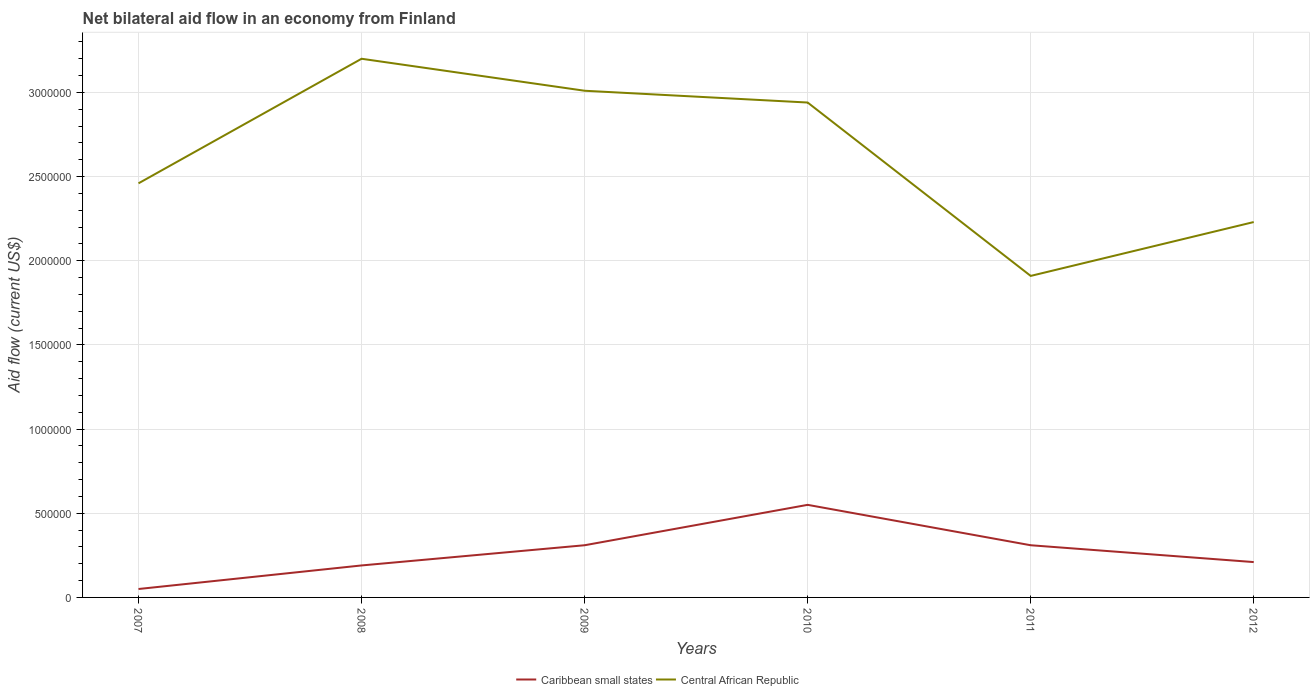Does the line corresponding to Central African Republic intersect with the line corresponding to Caribbean small states?
Give a very brief answer. No. Is the number of lines equal to the number of legend labels?
Your answer should be very brief. Yes. Across all years, what is the maximum net bilateral aid flow in Caribbean small states?
Provide a short and direct response. 5.00e+04. What is the total net bilateral aid flow in Central African Republic in the graph?
Your answer should be compact. 1.29e+06. What is the difference between the highest and the second highest net bilateral aid flow in Central African Republic?
Give a very brief answer. 1.29e+06. What is the difference between the highest and the lowest net bilateral aid flow in Central African Republic?
Your answer should be very brief. 3. Is the net bilateral aid flow in Caribbean small states strictly greater than the net bilateral aid flow in Central African Republic over the years?
Your response must be concise. Yes. How many lines are there?
Provide a short and direct response. 2. What is the difference between two consecutive major ticks on the Y-axis?
Give a very brief answer. 5.00e+05. Does the graph contain grids?
Your answer should be compact. Yes. What is the title of the graph?
Your answer should be compact. Net bilateral aid flow in an economy from Finland. Does "Cyprus" appear as one of the legend labels in the graph?
Your answer should be compact. No. What is the label or title of the Y-axis?
Your answer should be very brief. Aid flow (current US$). What is the Aid flow (current US$) of Central African Republic in 2007?
Your answer should be compact. 2.46e+06. What is the Aid flow (current US$) of Caribbean small states in 2008?
Offer a very short reply. 1.90e+05. What is the Aid flow (current US$) in Central African Republic in 2008?
Ensure brevity in your answer.  3.20e+06. What is the Aid flow (current US$) of Central African Republic in 2009?
Keep it short and to the point. 3.01e+06. What is the Aid flow (current US$) in Central African Republic in 2010?
Ensure brevity in your answer.  2.94e+06. What is the Aid flow (current US$) in Central African Republic in 2011?
Your answer should be compact. 1.91e+06. What is the Aid flow (current US$) in Central African Republic in 2012?
Provide a succinct answer. 2.23e+06. Across all years, what is the maximum Aid flow (current US$) of Central African Republic?
Offer a very short reply. 3.20e+06. Across all years, what is the minimum Aid flow (current US$) of Central African Republic?
Provide a short and direct response. 1.91e+06. What is the total Aid flow (current US$) of Caribbean small states in the graph?
Your response must be concise. 1.62e+06. What is the total Aid flow (current US$) of Central African Republic in the graph?
Provide a short and direct response. 1.58e+07. What is the difference between the Aid flow (current US$) in Caribbean small states in 2007 and that in 2008?
Offer a terse response. -1.40e+05. What is the difference between the Aid flow (current US$) of Central African Republic in 2007 and that in 2008?
Give a very brief answer. -7.40e+05. What is the difference between the Aid flow (current US$) in Central African Republic in 2007 and that in 2009?
Provide a succinct answer. -5.50e+05. What is the difference between the Aid flow (current US$) of Caribbean small states in 2007 and that in 2010?
Provide a succinct answer. -5.00e+05. What is the difference between the Aid flow (current US$) of Central African Republic in 2007 and that in 2010?
Offer a very short reply. -4.80e+05. What is the difference between the Aid flow (current US$) of Central African Republic in 2007 and that in 2011?
Your response must be concise. 5.50e+05. What is the difference between the Aid flow (current US$) in Caribbean small states in 2007 and that in 2012?
Offer a very short reply. -1.60e+05. What is the difference between the Aid flow (current US$) of Central African Republic in 2007 and that in 2012?
Your answer should be very brief. 2.30e+05. What is the difference between the Aid flow (current US$) of Caribbean small states in 2008 and that in 2009?
Give a very brief answer. -1.20e+05. What is the difference between the Aid flow (current US$) in Caribbean small states in 2008 and that in 2010?
Provide a succinct answer. -3.60e+05. What is the difference between the Aid flow (current US$) in Central African Republic in 2008 and that in 2010?
Make the answer very short. 2.60e+05. What is the difference between the Aid flow (current US$) in Central African Republic in 2008 and that in 2011?
Offer a terse response. 1.29e+06. What is the difference between the Aid flow (current US$) of Caribbean small states in 2008 and that in 2012?
Your answer should be very brief. -2.00e+04. What is the difference between the Aid flow (current US$) in Central African Republic in 2008 and that in 2012?
Provide a succinct answer. 9.70e+05. What is the difference between the Aid flow (current US$) of Central African Republic in 2009 and that in 2010?
Ensure brevity in your answer.  7.00e+04. What is the difference between the Aid flow (current US$) in Central African Republic in 2009 and that in 2011?
Ensure brevity in your answer.  1.10e+06. What is the difference between the Aid flow (current US$) in Central African Republic in 2009 and that in 2012?
Offer a very short reply. 7.80e+05. What is the difference between the Aid flow (current US$) of Caribbean small states in 2010 and that in 2011?
Keep it short and to the point. 2.40e+05. What is the difference between the Aid flow (current US$) of Central African Republic in 2010 and that in 2011?
Your answer should be compact. 1.03e+06. What is the difference between the Aid flow (current US$) in Caribbean small states in 2010 and that in 2012?
Your answer should be very brief. 3.40e+05. What is the difference between the Aid flow (current US$) of Central African Republic in 2010 and that in 2012?
Ensure brevity in your answer.  7.10e+05. What is the difference between the Aid flow (current US$) in Caribbean small states in 2011 and that in 2012?
Make the answer very short. 1.00e+05. What is the difference between the Aid flow (current US$) in Central African Republic in 2011 and that in 2012?
Your response must be concise. -3.20e+05. What is the difference between the Aid flow (current US$) of Caribbean small states in 2007 and the Aid flow (current US$) of Central African Republic in 2008?
Your answer should be compact. -3.15e+06. What is the difference between the Aid flow (current US$) in Caribbean small states in 2007 and the Aid flow (current US$) in Central African Republic in 2009?
Give a very brief answer. -2.96e+06. What is the difference between the Aid flow (current US$) in Caribbean small states in 2007 and the Aid flow (current US$) in Central African Republic in 2010?
Your answer should be compact. -2.89e+06. What is the difference between the Aid flow (current US$) of Caribbean small states in 2007 and the Aid flow (current US$) of Central African Republic in 2011?
Your answer should be very brief. -1.86e+06. What is the difference between the Aid flow (current US$) in Caribbean small states in 2007 and the Aid flow (current US$) in Central African Republic in 2012?
Provide a succinct answer. -2.18e+06. What is the difference between the Aid flow (current US$) of Caribbean small states in 2008 and the Aid flow (current US$) of Central African Republic in 2009?
Provide a succinct answer. -2.82e+06. What is the difference between the Aid flow (current US$) of Caribbean small states in 2008 and the Aid flow (current US$) of Central African Republic in 2010?
Your answer should be very brief. -2.75e+06. What is the difference between the Aid flow (current US$) in Caribbean small states in 2008 and the Aid flow (current US$) in Central African Republic in 2011?
Give a very brief answer. -1.72e+06. What is the difference between the Aid flow (current US$) in Caribbean small states in 2008 and the Aid flow (current US$) in Central African Republic in 2012?
Offer a terse response. -2.04e+06. What is the difference between the Aid flow (current US$) of Caribbean small states in 2009 and the Aid flow (current US$) of Central African Republic in 2010?
Your answer should be compact. -2.63e+06. What is the difference between the Aid flow (current US$) in Caribbean small states in 2009 and the Aid flow (current US$) in Central African Republic in 2011?
Offer a terse response. -1.60e+06. What is the difference between the Aid flow (current US$) of Caribbean small states in 2009 and the Aid flow (current US$) of Central African Republic in 2012?
Provide a short and direct response. -1.92e+06. What is the difference between the Aid flow (current US$) of Caribbean small states in 2010 and the Aid flow (current US$) of Central African Republic in 2011?
Your answer should be very brief. -1.36e+06. What is the difference between the Aid flow (current US$) of Caribbean small states in 2010 and the Aid flow (current US$) of Central African Republic in 2012?
Make the answer very short. -1.68e+06. What is the difference between the Aid flow (current US$) of Caribbean small states in 2011 and the Aid flow (current US$) of Central African Republic in 2012?
Your response must be concise. -1.92e+06. What is the average Aid flow (current US$) in Central African Republic per year?
Your answer should be compact. 2.62e+06. In the year 2007, what is the difference between the Aid flow (current US$) in Caribbean small states and Aid flow (current US$) in Central African Republic?
Your answer should be very brief. -2.41e+06. In the year 2008, what is the difference between the Aid flow (current US$) in Caribbean small states and Aid flow (current US$) in Central African Republic?
Give a very brief answer. -3.01e+06. In the year 2009, what is the difference between the Aid flow (current US$) in Caribbean small states and Aid flow (current US$) in Central African Republic?
Your answer should be very brief. -2.70e+06. In the year 2010, what is the difference between the Aid flow (current US$) of Caribbean small states and Aid flow (current US$) of Central African Republic?
Provide a succinct answer. -2.39e+06. In the year 2011, what is the difference between the Aid flow (current US$) in Caribbean small states and Aid flow (current US$) in Central African Republic?
Keep it short and to the point. -1.60e+06. In the year 2012, what is the difference between the Aid flow (current US$) in Caribbean small states and Aid flow (current US$) in Central African Republic?
Keep it short and to the point. -2.02e+06. What is the ratio of the Aid flow (current US$) in Caribbean small states in 2007 to that in 2008?
Provide a short and direct response. 0.26. What is the ratio of the Aid flow (current US$) of Central African Republic in 2007 to that in 2008?
Your answer should be very brief. 0.77. What is the ratio of the Aid flow (current US$) of Caribbean small states in 2007 to that in 2009?
Ensure brevity in your answer.  0.16. What is the ratio of the Aid flow (current US$) in Central African Republic in 2007 to that in 2009?
Ensure brevity in your answer.  0.82. What is the ratio of the Aid flow (current US$) in Caribbean small states in 2007 to that in 2010?
Your answer should be compact. 0.09. What is the ratio of the Aid flow (current US$) in Central African Republic in 2007 to that in 2010?
Ensure brevity in your answer.  0.84. What is the ratio of the Aid flow (current US$) of Caribbean small states in 2007 to that in 2011?
Offer a very short reply. 0.16. What is the ratio of the Aid flow (current US$) of Central African Republic in 2007 to that in 2011?
Keep it short and to the point. 1.29. What is the ratio of the Aid flow (current US$) in Caribbean small states in 2007 to that in 2012?
Provide a succinct answer. 0.24. What is the ratio of the Aid flow (current US$) of Central African Republic in 2007 to that in 2012?
Your response must be concise. 1.1. What is the ratio of the Aid flow (current US$) in Caribbean small states in 2008 to that in 2009?
Keep it short and to the point. 0.61. What is the ratio of the Aid flow (current US$) of Central African Republic in 2008 to that in 2009?
Give a very brief answer. 1.06. What is the ratio of the Aid flow (current US$) in Caribbean small states in 2008 to that in 2010?
Make the answer very short. 0.35. What is the ratio of the Aid flow (current US$) in Central African Republic in 2008 to that in 2010?
Your answer should be very brief. 1.09. What is the ratio of the Aid flow (current US$) in Caribbean small states in 2008 to that in 2011?
Your answer should be very brief. 0.61. What is the ratio of the Aid flow (current US$) of Central African Republic in 2008 to that in 2011?
Ensure brevity in your answer.  1.68. What is the ratio of the Aid flow (current US$) of Caribbean small states in 2008 to that in 2012?
Provide a short and direct response. 0.9. What is the ratio of the Aid flow (current US$) in Central African Republic in 2008 to that in 2012?
Offer a very short reply. 1.44. What is the ratio of the Aid flow (current US$) of Caribbean small states in 2009 to that in 2010?
Make the answer very short. 0.56. What is the ratio of the Aid flow (current US$) in Central African Republic in 2009 to that in 2010?
Your answer should be compact. 1.02. What is the ratio of the Aid flow (current US$) in Central African Republic in 2009 to that in 2011?
Your response must be concise. 1.58. What is the ratio of the Aid flow (current US$) in Caribbean small states in 2009 to that in 2012?
Offer a terse response. 1.48. What is the ratio of the Aid flow (current US$) of Central African Republic in 2009 to that in 2012?
Your response must be concise. 1.35. What is the ratio of the Aid flow (current US$) of Caribbean small states in 2010 to that in 2011?
Offer a very short reply. 1.77. What is the ratio of the Aid flow (current US$) in Central African Republic in 2010 to that in 2011?
Your response must be concise. 1.54. What is the ratio of the Aid flow (current US$) of Caribbean small states in 2010 to that in 2012?
Keep it short and to the point. 2.62. What is the ratio of the Aid flow (current US$) in Central African Republic in 2010 to that in 2012?
Keep it short and to the point. 1.32. What is the ratio of the Aid flow (current US$) of Caribbean small states in 2011 to that in 2012?
Offer a terse response. 1.48. What is the ratio of the Aid flow (current US$) in Central African Republic in 2011 to that in 2012?
Provide a succinct answer. 0.86. What is the difference between the highest and the second highest Aid flow (current US$) in Central African Republic?
Provide a short and direct response. 1.90e+05. What is the difference between the highest and the lowest Aid flow (current US$) in Caribbean small states?
Ensure brevity in your answer.  5.00e+05. What is the difference between the highest and the lowest Aid flow (current US$) of Central African Republic?
Keep it short and to the point. 1.29e+06. 